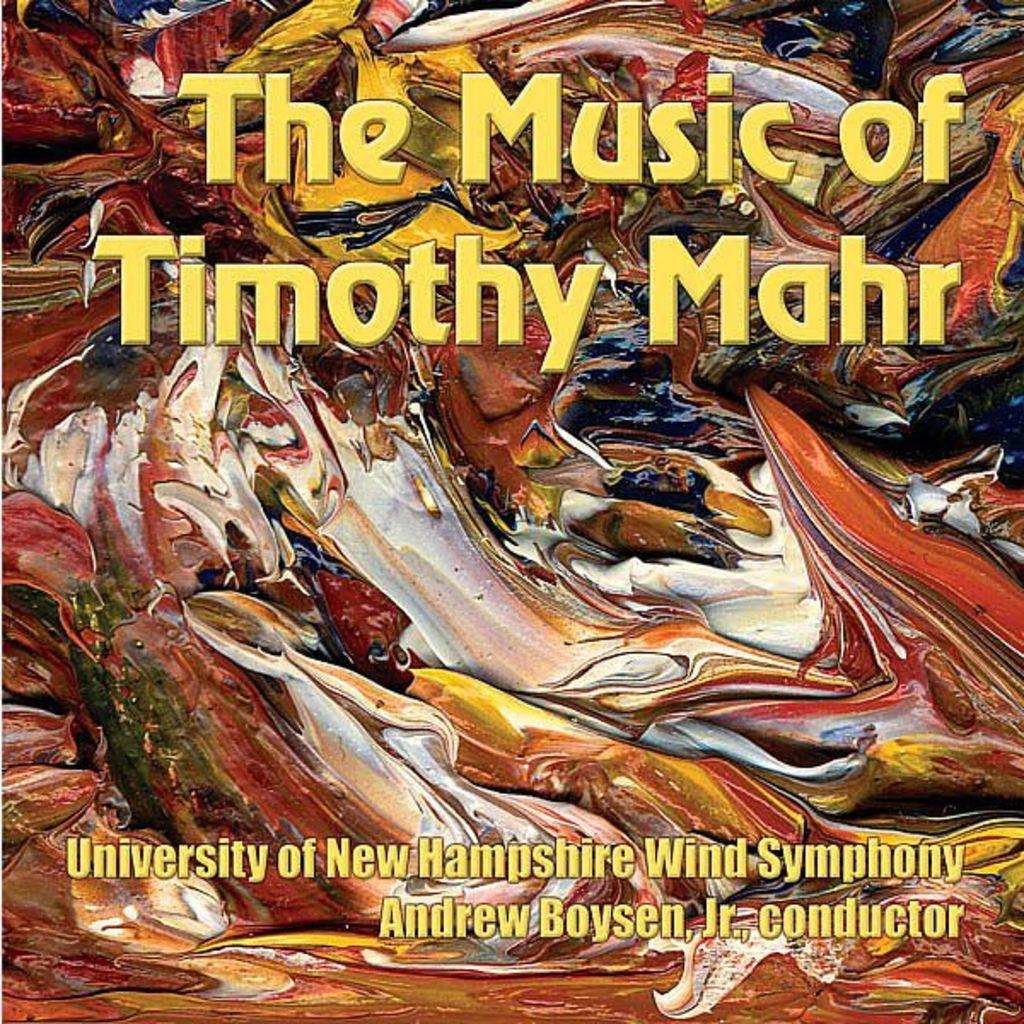<image>
Render a clear and concise summary of the photo. a cover page that says 'the music of timothy mahr' on it 